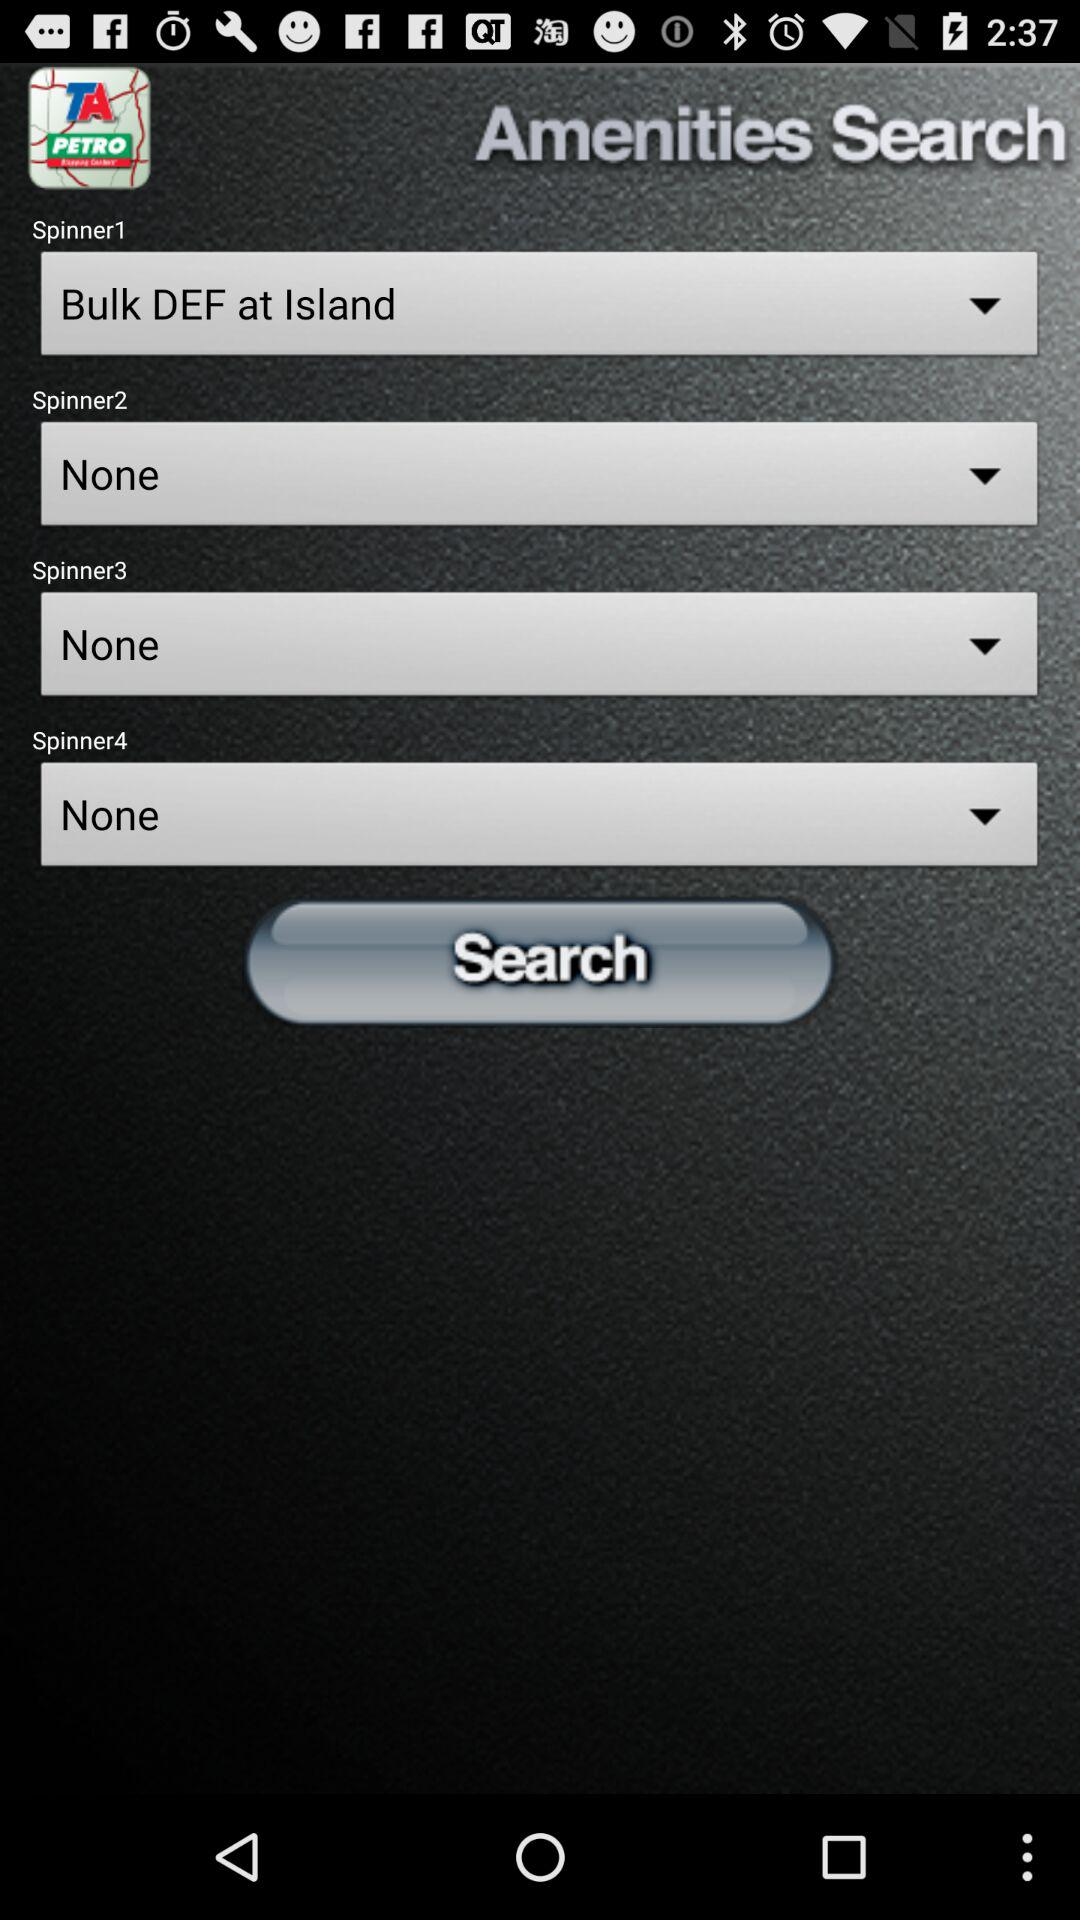What is the current setting for the "Spinner3"? The current setting for the "Spinner3" is "None". 